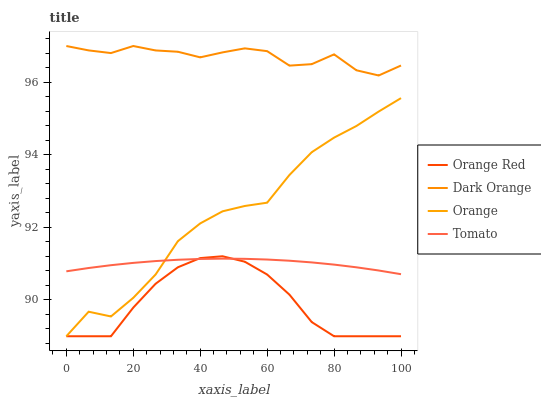Does Orange Red have the minimum area under the curve?
Answer yes or no. Yes. Does Dark Orange have the maximum area under the curve?
Answer yes or no. Yes. Does Tomato have the minimum area under the curve?
Answer yes or no. No. Does Tomato have the maximum area under the curve?
Answer yes or no. No. Is Tomato the smoothest?
Answer yes or no. Yes. Is Orange the roughest?
Answer yes or no. Yes. Is Dark Orange the smoothest?
Answer yes or no. No. Is Dark Orange the roughest?
Answer yes or no. No. Does Tomato have the lowest value?
Answer yes or no. No. Does Dark Orange have the highest value?
Answer yes or no. Yes. Does Tomato have the highest value?
Answer yes or no. No. Is Orange Red less than Dark Orange?
Answer yes or no. Yes. Is Dark Orange greater than Tomato?
Answer yes or no. Yes. Does Orange Red intersect Dark Orange?
Answer yes or no. No. 